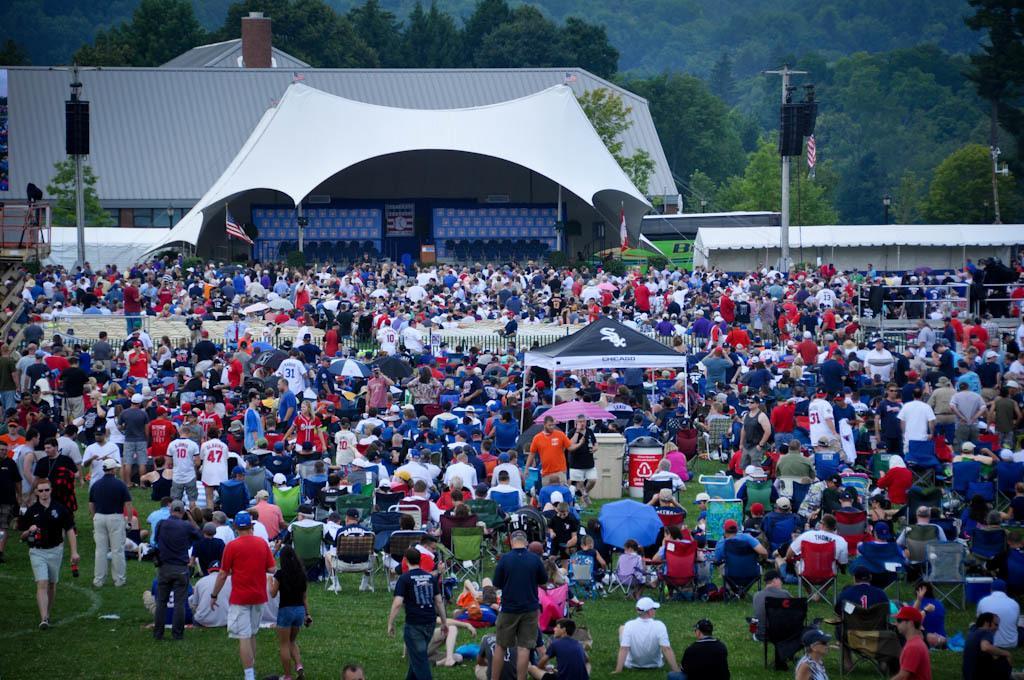Please provide a concise description of this image. In this image, we can see a group of people. Few are sitting, standing and walking. Here we can see a stall, umbrella, dustbins, poles, grass and few objects. Top of the image, we can see shed, tent, trees, poles, flags and pillars. 